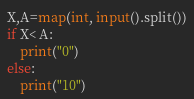Convert code to text. <code><loc_0><loc_0><loc_500><loc_500><_Python_>X,A=map(int, input().split())
if X< A:
    print("0")
else:
    print("10")
</code> 